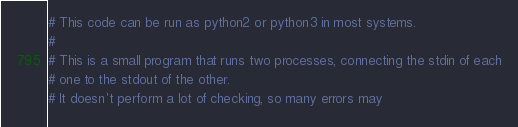<code> <loc_0><loc_0><loc_500><loc_500><_Python_># This code can be run as python2 or python3 in most systems.
#
# This is a small program that runs two processes, connecting the stdin of each
# one to the stdout of the other.
# It doesn't perform a lot of checking, so many errors may</code> 